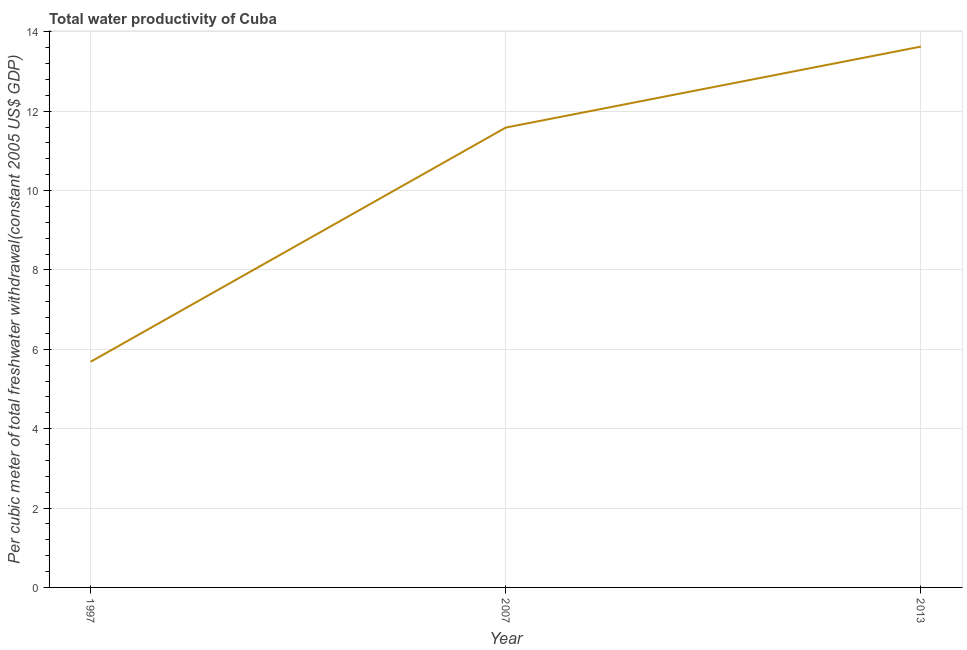What is the total water productivity in 2013?
Keep it short and to the point. 13.63. Across all years, what is the maximum total water productivity?
Provide a short and direct response. 13.63. Across all years, what is the minimum total water productivity?
Ensure brevity in your answer.  5.69. In which year was the total water productivity maximum?
Your answer should be compact. 2013. In which year was the total water productivity minimum?
Provide a succinct answer. 1997. What is the sum of the total water productivity?
Make the answer very short. 30.9. What is the difference between the total water productivity in 1997 and 2007?
Your answer should be very brief. -5.9. What is the average total water productivity per year?
Give a very brief answer. 10.3. What is the median total water productivity?
Your answer should be compact. 11.59. Do a majority of the years between 1997 and 2007 (inclusive) have total water productivity greater than 5.2 US$?
Your response must be concise. Yes. What is the ratio of the total water productivity in 1997 to that in 2007?
Your answer should be compact. 0.49. Is the total water productivity in 1997 less than that in 2013?
Your answer should be compact. Yes. What is the difference between the highest and the second highest total water productivity?
Make the answer very short. 2.04. Is the sum of the total water productivity in 2007 and 2013 greater than the maximum total water productivity across all years?
Provide a short and direct response. Yes. What is the difference between the highest and the lowest total water productivity?
Keep it short and to the point. 7.94. Does the total water productivity monotonically increase over the years?
Your answer should be very brief. Yes. How many years are there in the graph?
Offer a terse response. 3. Are the values on the major ticks of Y-axis written in scientific E-notation?
Offer a terse response. No. What is the title of the graph?
Your answer should be compact. Total water productivity of Cuba. What is the label or title of the Y-axis?
Ensure brevity in your answer.  Per cubic meter of total freshwater withdrawal(constant 2005 US$ GDP). What is the Per cubic meter of total freshwater withdrawal(constant 2005 US$ GDP) of 1997?
Provide a succinct answer. 5.69. What is the Per cubic meter of total freshwater withdrawal(constant 2005 US$ GDP) of 2007?
Ensure brevity in your answer.  11.59. What is the Per cubic meter of total freshwater withdrawal(constant 2005 US$ GDP) of 2013?
Keep it short and to the point. 13.63. What is the difference between the Per cubic meter of total freshwater withdrawal(constant 2005 US$ GDP) in 1997 and 2007?
Provide a succinct answer. -5.9. What is the difference between the Per cubic meter of total freshwater withdrawal(constant 2005 US$ GDP) in 1997 and 2013?
Provide a short and direct response. -7.94. What is the difference between the Per cubic meter of total freshwater withdrawal(constant 2005 US$ GDP) in 2007 and 2013?
Your response must be concise. -2.04. What is the ratio of the Per cubic meter of total freshwater withdrawal(constant 2005 US$ GDP) in 1997 to that in 2007?
Offer a very short reply. 0.49. What is the ratio of the Per cubic meter of total freshwater withdrawal(constant 2005 US$ GDP) in 1997 to that in 2013?
Ensure brevity in your answer.  0.42. 